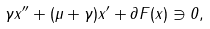<formula> <loc_0><loc_0><loc_500><loc_500>\gamma x ^ { \prime \prime } + ( \mu + \gamma ) x ^ { \prime } + \partial F ( x ) \ni 0 ,</formula> 